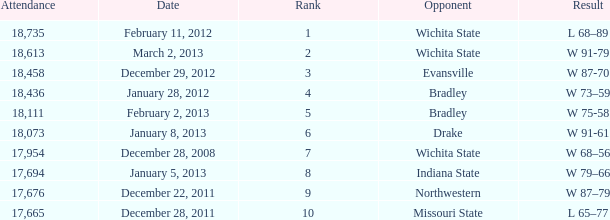In a match against northwestern with an attendance of fewer than 18,073, what is the corresponding rank? 9.0. 